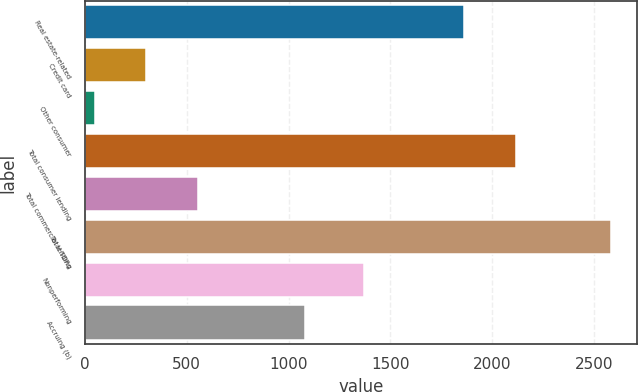Convert chart to OTSL. <chart><loc_0><loc_0><loc_500><loc_500><bar_chart><fcel>Real estate-related<fcel>Credit card<fcel>Other consumer<fcel>Total consumer lending<fcel>Total commercial lending<fcel>Total TDRs<fcel>Nonperforming<fcel>Accruing (b)<nl><fcel>1864<fcel>300.6<fcel>47<fcel>2117.6<fcel>554.2<fcel>2583<fcel>1370<fcel>1083<nl></chart> 